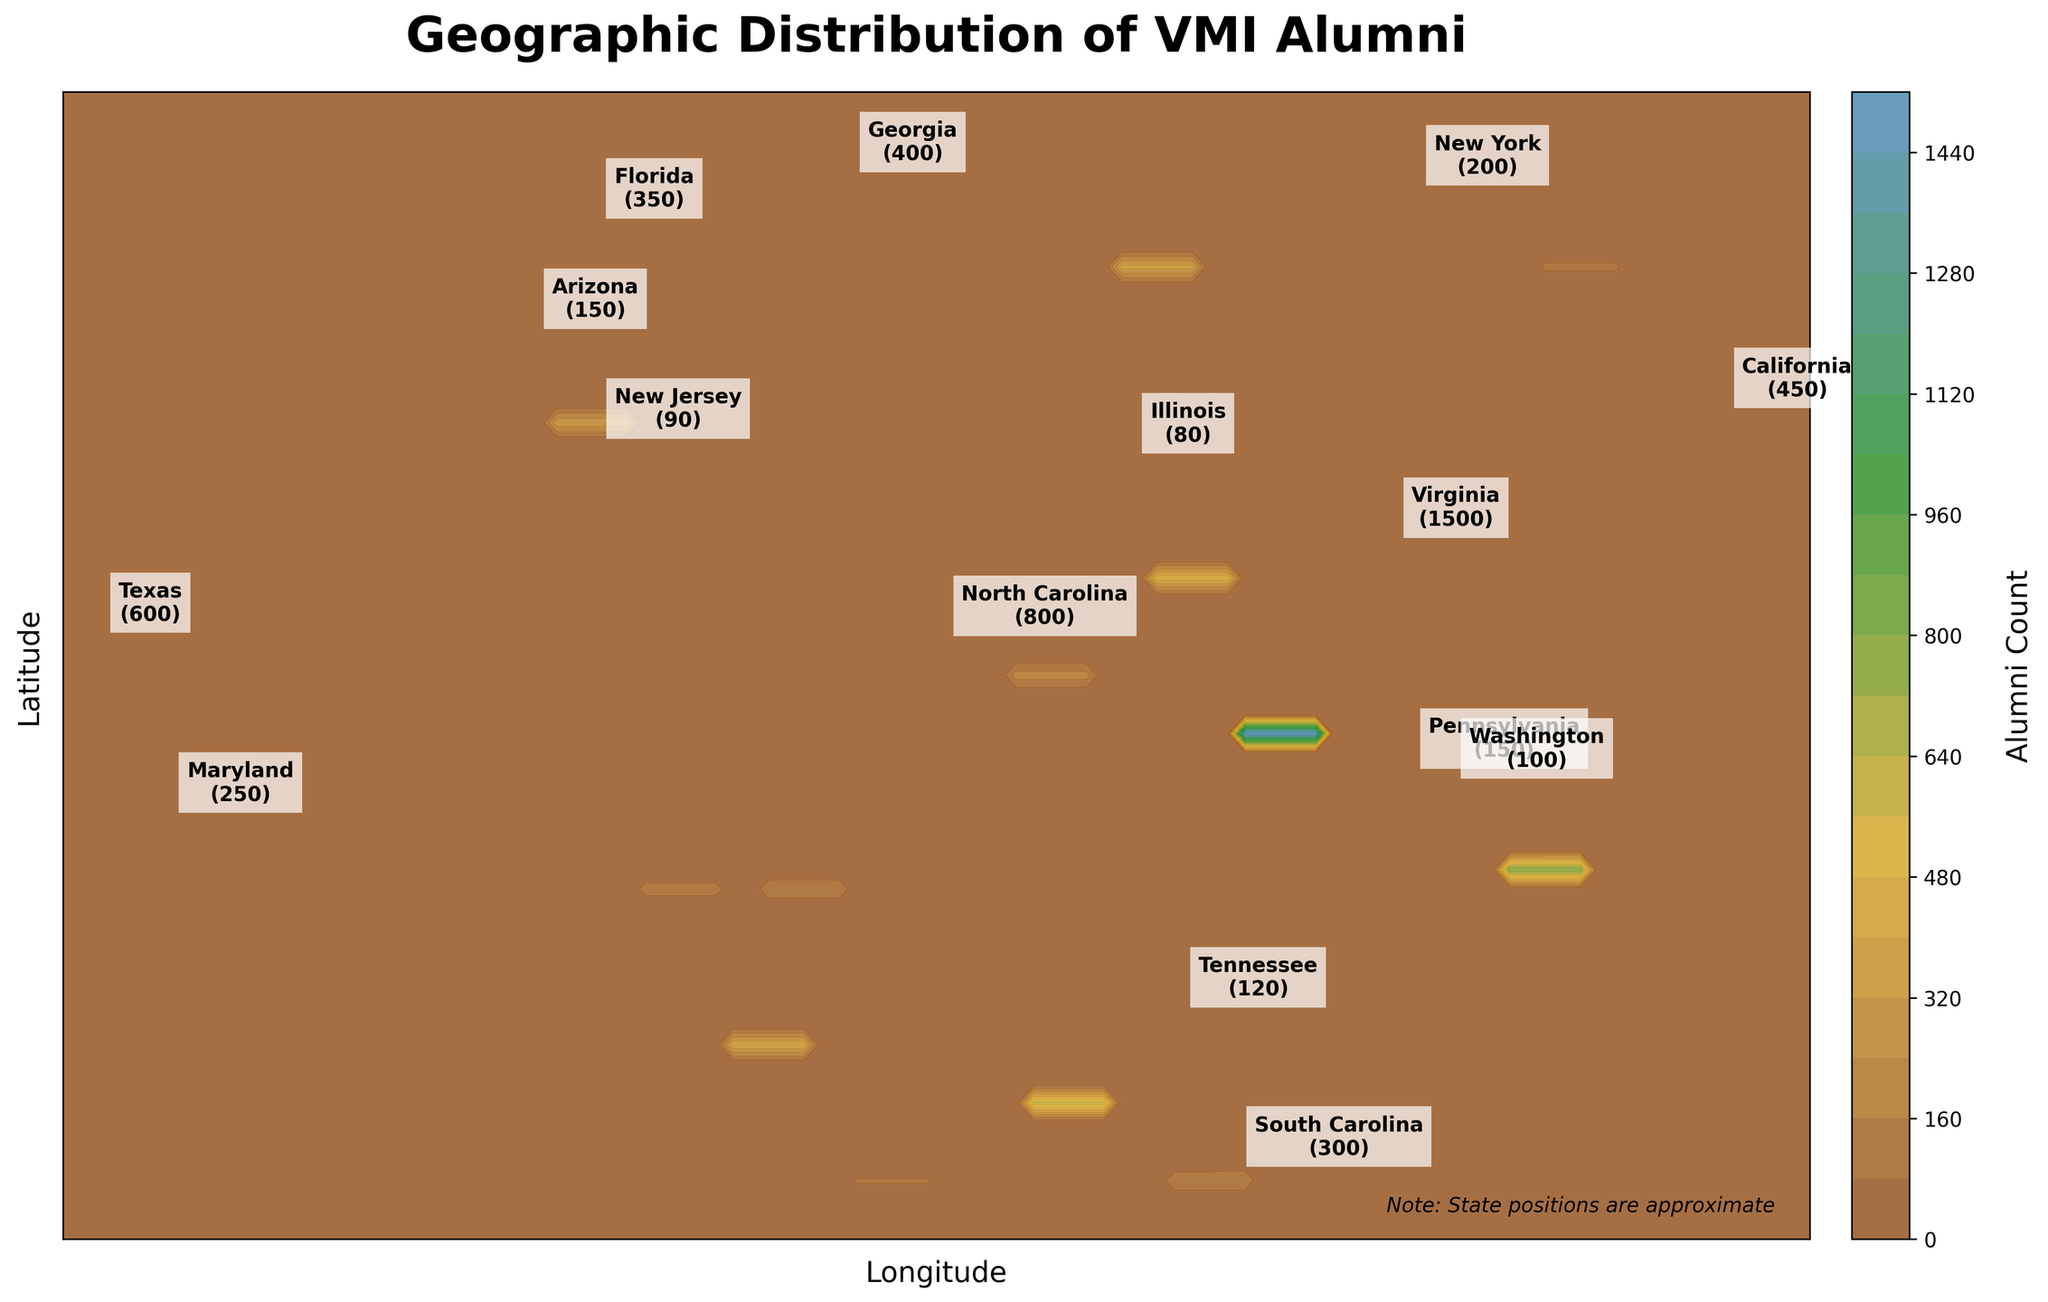Which state has the highest number of alumni? By looking at the labels on the contour plot, Virginia is seen to have the highest alumni count, labeled as 1500.
Answer: Virginia What does the contour plot title indicate? The title at the top of the plot clearly states "Geographic Distribution of VMI Alumni," indicating that the visual represents the distribution of alumni across different states.
Answer: Geographic Distribution of VMI Alumni How many alumni are there in Texas? Referencing the labeled points on the contour plot, Texas has an alumni count of 600.
Answer: 600 Compare the alumni counts for Georgia and Florida. Which state has more alumni? By inspecting the labels on the plot, Georgia has 400 alumni, and Florida has 350 alumni. Therefore, Georgia has more alumni than Florida.
Answer: Georgia What is the alumni count range represented in the color bar? Observing the color bar on the side of the contour plot shows that it ranges from low counts (in lighter colors) to higher counts (in darker colors), but specific numerical ranges are not visible. However, the plot top level is indicated by state like Virginia with count 1500.
Answer: Not explicitly labeled (up to 1500 in Virginia) Where does New York stand in terms of alumni count? The label for New York on the plot shows an alumni count of 200. Although not among the highest, it has a significant number of alumni.
Answer: 200 Are there any states with an alumni count of fewer than 10? If so, name one. Inspecting the lower bound of the labels and smaller text annotations in the contour plot reveals states like Maine with 8 alumni who meet the criteria of fewer than 10 alumni.
Answer: Maine Which has more alumni, Maryland or South Carolina? Looking at the labels, Maryland has 250 alumni, while South Carolina has 300. Thus, South Carolina has more alumni than Maryland.
Answer: South Carolina Identify two states with approximately equal numbers of alumni. Reviewing the data, both Pennsylvania and Arizona have been labeled with an alumni count of 150.
Answer: Pennsylvania & Arizona How many states have an alumni count of 80 or above? There are 15 mentioned states with labels displayed, and by identifying those with counts of 80 or more, one includes (Virginia, North Carolina, Texas, California, Georgia, Florida, South Carolina, Maryland, New York, Pennsylvania, Arizona, Tennessee, Washington, New Jersey, Illinois). This totals to 15 states.
Answer: 15 